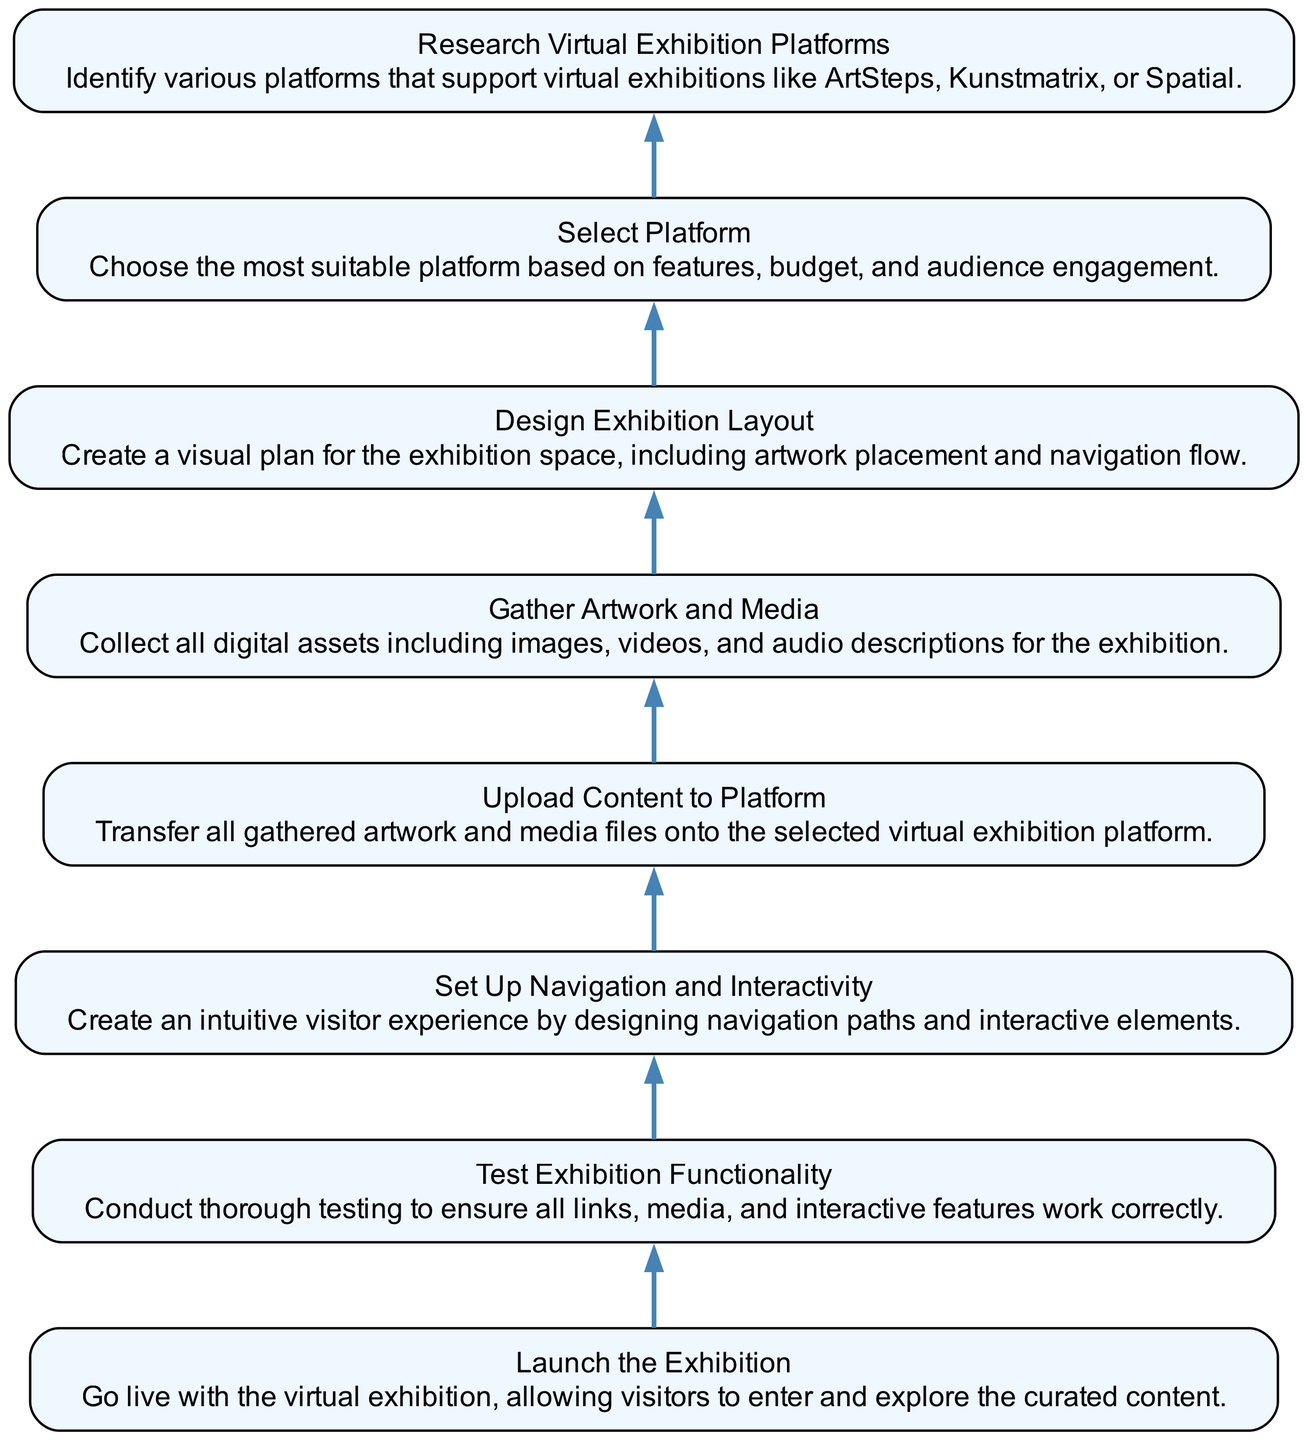What is the first step in the virtual exhibition setup workflow? The first step in the workflow is "Research Virtual Exhibition Platforms," which involves identifying various platforms that support virtual exhibitions. It is the initial point of the workflow that leads to the subsequent steps.
Answer: Research Virtual Exhibition Platforms How many nodes are present in the diagram? The diagram contains eight nodes, each representing a distinct step in the virtual exhibition setup process. These nodes range from research to the final launch of the exhibition.
Answer: Eight What comes immediately before "Launch the Exhibition"? The step that comes immediately before "Launch the Exhibition" is "Test Exhibition Functionality." This step ensures that everything is working properly before going live to visitors.
Answer: Test Exhibition Functionality Which task involves creating a visual plan for the exhibition space? The task that involves creating a visual plan for the exhibition space is "Design Exhibition Layout." This step is crucial for determining the placement of artworks and the overall navigation flow.
Answer: Design Exhibition Layout How many edges connect the nodes in the workflow? There are seven edges connecting the nodes in the workflow. Each edge indicates the flow from one task to the next in the setup process, leading down to the final launch.
Answer: Seven What is the main goal of "Set Up Navigation and Interactivity"? The main goal of "Set Up Navigation and Interactivity" is to create an intuitive visitor experience by designing navigation paths and interactive elements, enhancing user engagement during the exhibition.
Answer: Create an intuitive visitor experience What is the overall direction of the flow in the diagram? The overall direction of the flow in the diagram is bottom-up, indicating a sequential process where each task supports the completion of the next task, culminating in the launch.
Answer: Bottom-up Which task requires uploading content to the selected platform? The task that requires uploading content to the selected platform is "Upload Content to Platform." This step follows the gathering of artwork and media necessary for the exhibition.
Answer: Upload Content to Platform 